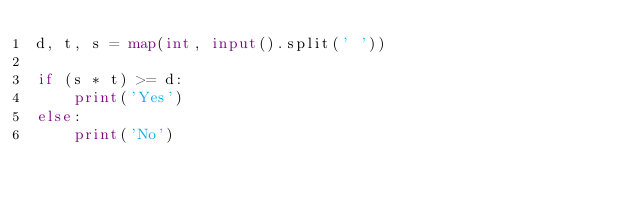<code> <loc_0><loc_0><loc_500><loc_500><_Python_>d, t, s = map(int, input().split(' '))

if (s * t) >= d:
    print('Yes')
else:
    print('No')
</code> 